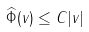<formula> <loc_0><loc_0><loc_500><loc_500>\widehat { \Phi } ( v ) \leq C | v |</formula> 